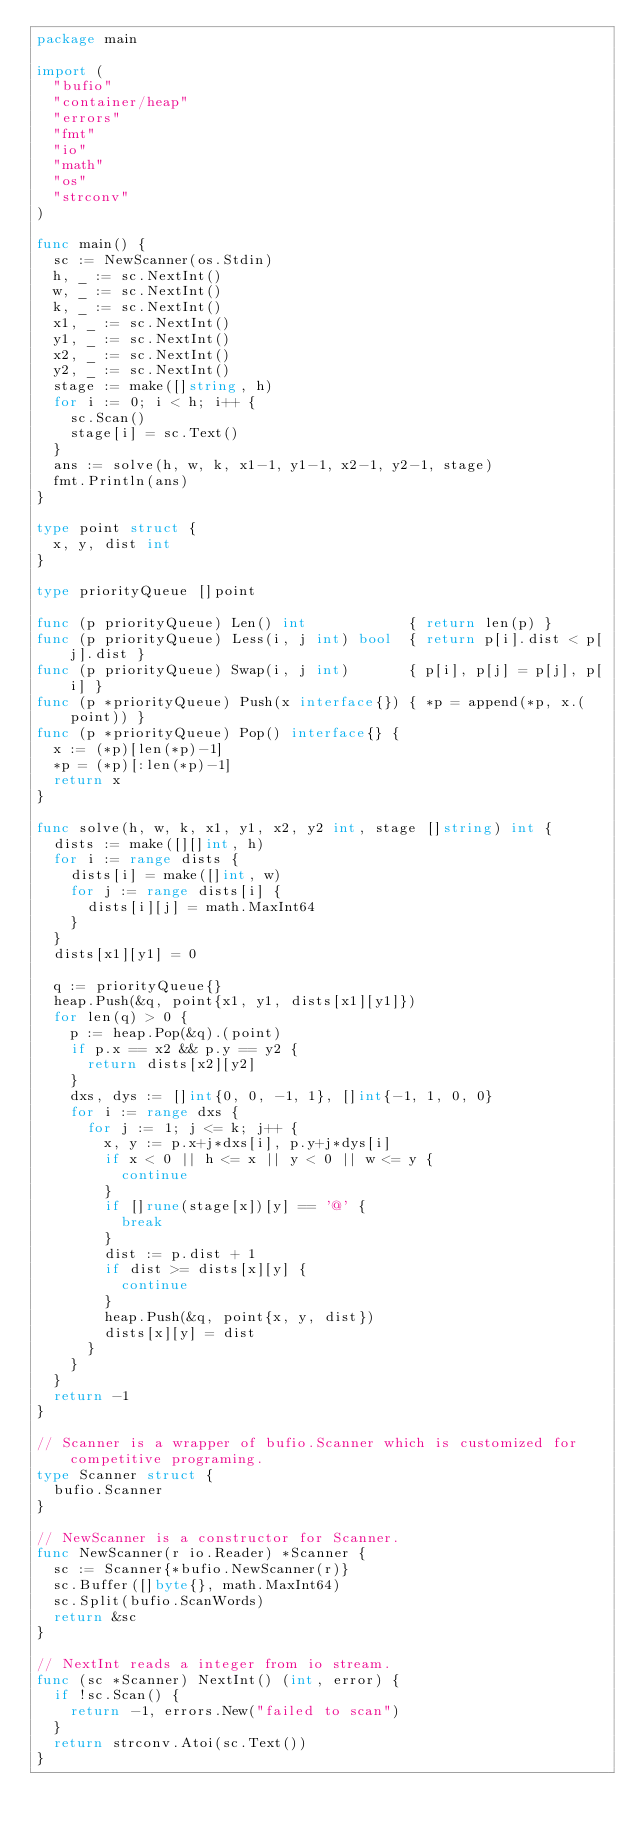Convert code to text. <code><loc_0><loc_0><loc_500><loc_500><_Go_>package main

import (
	"bufio"
	"container/heap"
	"errors"
	"fmt"
	"io"
	"math"
	"os"
	"strconv"
)

func main() {
	sc := NewScanner(os.Stdin)
	h, _ := sc.NextInt()
	w, _ := sc.NextInt()
	k, _ := sc.NextInt()
	x1, _ := sc.NextInt()
	y1, _ := sc.NextInt()
	x2, _ := sc.NextInt()
	y2, _ := sc.NextInt()
	stage := make([]string, h)
	for i := 0; i < h; i++ {
		sc.Scan()
		stage[i] = sc.Text()
	}
	ans := solve(h, w, k, x1-1, y1-1, x2-1, y2-1, stage)
	fmt.Println(ans)
}

type point struct {
	x, y, dist int
}

type priorityQueue []point

func (p priorityQueue) Len() int            { return len(p) }
func (p priorityQueue) Less(i, j int) bool  { return p[i].dist < p[j].dist }
func (p priorityQueue) Swap(i, j int)       { p[i], p[j] = p[j], p[i] }
func (p *priorityQueue) Push(x interface{}) { *p = append(*p, x.(point)) }
func (p *priorityQueue) Pop() interface{} {
	x := (*p)[len(*p)-1]
	*p = (*p)[:len(*p)-1]
	return x
}

func solve(h, w, k, x1, y1, x2, y2 int, stage []string) int {
	dists := make([][]int, h)
	for i := range dists {
		dists[i] = make([]int, w)
		for j := range dists[i] {
			dists[i][j] = math.MaxInt64
		}
	}
	dists[x1][y1] = 0

	q := priorityQueue{}
	heap.Push(&q, point{x1, y1, dists[x1][y1]})
	for len(q) > 0 {
		p := heap.Pop(&q).(point)
		if p.x == x2 && p.y == y2 {
			return dists[x2][y2]
		}
		dxs, dys := []int{0, 0, -1, 1}, []int{-1, 1, 0, 0}
		for i := range dxs {
			for j := 1; j <= k; j++ {
				x, y := p.x+j*dxs[i], p.y+j*dys[i]
				if x < 0 || h <= x || y < 0 || w <= y {
					continue
				}
				if []rune(stage[x])[y] == '@' {
					break
				}
				dist := p.dist + 1
				if dist >= dists[x][y] {
					continue
				}
				heap.Push(&q, point{x, y, dist})
				dists[x][y] = dist
			}
		}
	}
	return -1
}

// Scanner is a wrapper of bufio.Scanner which is customized for competitive programing.
type Scanner struct {
	bufio.Scanner
}

// NewScanner is a constructor for Scanner.
func NewScanner(r io.Reader) *Scanner {
	sc := Scanner{*bufio.NewScanner(r)}
	sc.Buffer([]byte{}, math.MaxInt64)
	sc.Split(bufio.ScanWords)
	return &sc
}

// NextInt reads a integer from io stream.
func (sc *Scanner) NextInt() (int, error) {
	if !sc.Scan() {
		return -1, errors.New("failed to scan")
	}
	return strconv.Atoi(sc.Text())
}
</code> 